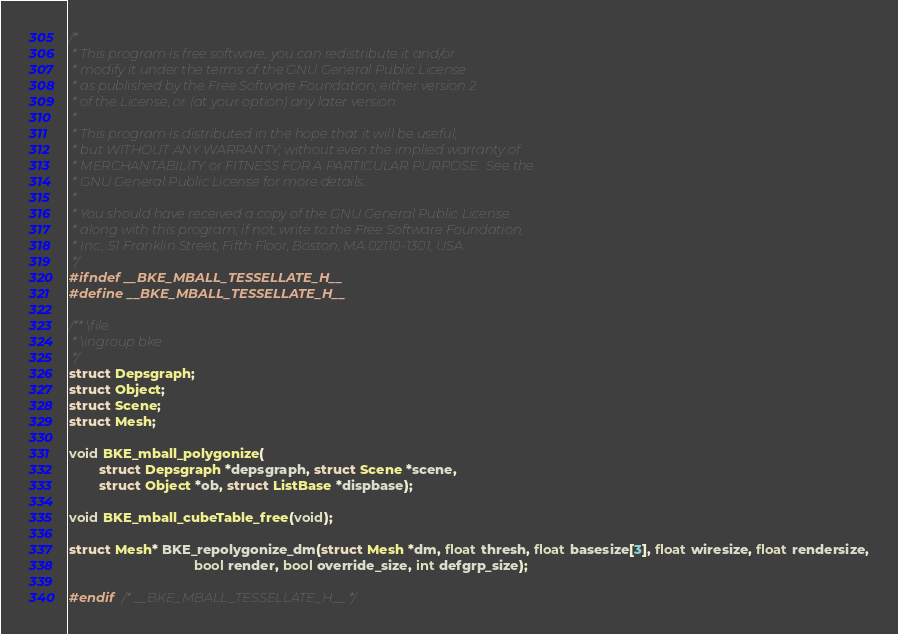Convert code to text. <code><loc_0><loc_0><loc_500><loc_500><_C_>/*
 * This program is free software; you can redistribute it and/or
 * modify it under the terms of the GNU General Public License
 * as published by the Free Software Foundation; either version 2
 * of the License, or (at your option) any later version.
 *
 * This program is distributed in the hope that it will be useful,
 * but WITHOUT ANY WARRANTY; without even the implied warranty of
 * MERCHANTABILITY or FITNESS FOR A PARTICULAR PURPOSE.  See the
 * GNU General Public License for more details.
 *
 * You should have received a copy of the GNU General Public License
 * along with this program; if not, write to the Free Software Foundation,
 * Inc., 51 Franklin Street, Fifth Floor, Boston, MA 02110-1301, USA.
 */
#ifndef __BKE_MBALL_TESSELLATE_H__
#define __BKE_MBALL_TESSELLATE_H__

/** \file
 * \ingroup bke
 */
struct Depsgraph;
struct Object;
struct Scene;
struct Mesh;

void BKE_mball_polygonize(
        struct Depsgraph *depsgraph, struct Scene *scene,
        struct Object *ob, struct ListBase *dispbase);

void BKE_mball_cubeTable_free(void);

struct Mesh* BKE_repolygonize_dm(struct Mesh *dm, float thresh, float basesize[3], float wiresize, float rendersize,
                                 bool render, bool override_size, int defgrp_size);

#endif  /* __BKE_MBALL_TESSELLATE_H__ */
</code> 